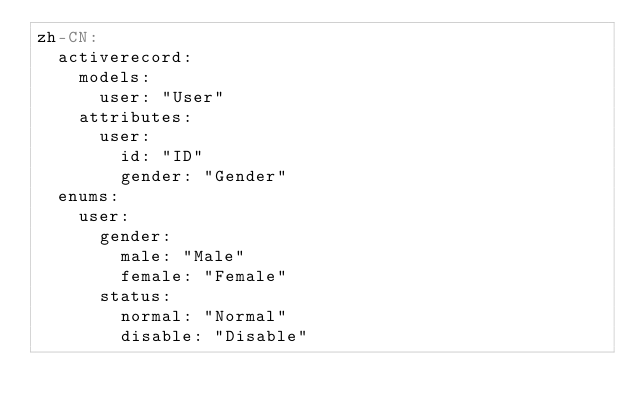<code> <loc_0><loc_0><loc_500><loc_500><_YAML_>zh-CN:
  activerecord:
    models:
      user: "User"
    attributes:
      user:
        id: "ID"
        gender: "Gender"
  enums:
    user:
      gender:
        male: "Male"
        female: "Female"
      status:
        normal: "Normal"
        disable: "Disable"</code> 